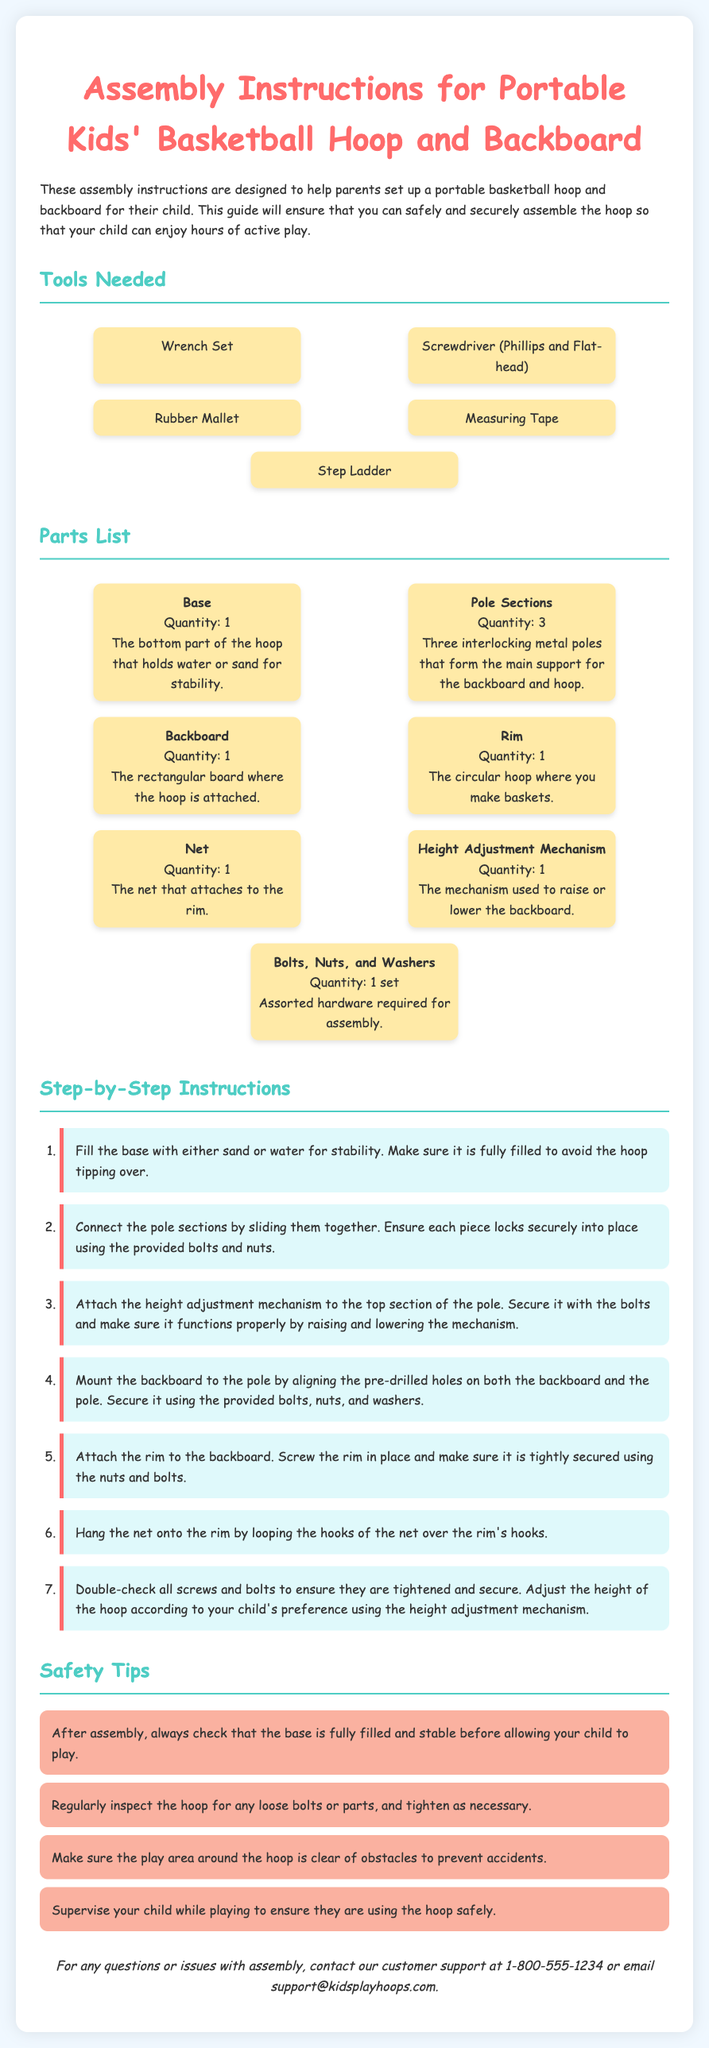What tools are needed for assembly? The tools listed in the document are necessary for piecing together the basketball hoop and backboard.
Answer: Wrench Set, Screwdriver, Rubber Mallet, Measuring Tape, Step Ladder How many pole sections are included? The number of pole sections is specified in the parts list of the document.
Answer: 3 What should the base be filled with? The document states that the base needs to be filled for stability during use.
Answer: Sand or Water What is the last step in the assembly instructions? The last action is to ensure the hoop is secure and adjusted to preference.
Answer: Double-check screw and bolt tightness What precaution is mentioned regarding the play area? The document highlights an essential safety precaution concerning the surroundings of the hoop during use.
Answer: Clear of obstacles 